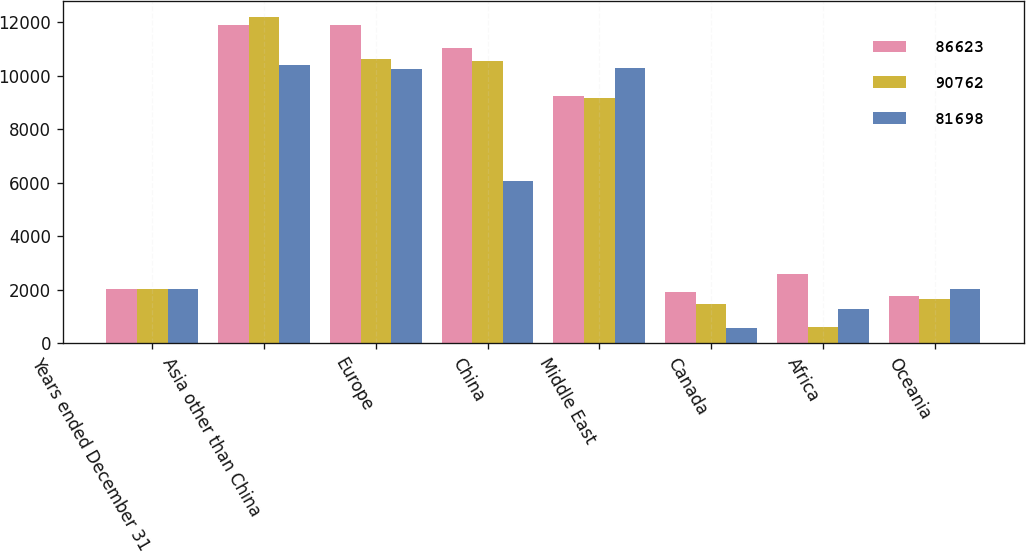Convert chart to OTSL. <chart><loc_0><loc_0><loc_500><loc_500><stacked_bar_chart><ecel><fcel>Years ended December 31<fcel>Asia other than China<fcel>Europe<fcel>China<fcel>Middle East<fcel>Canada<fcel>Africa<fcel>Oceania<nl><fcel>86623<fcel>2014<fcel>11900<fcel>11898<fcel>11029<fcel>9243<fcel>1901<fcel>2596<fcel>1757<nl><fcel>90762<fcel>2013<fcel>12200<fcel>10622<fcel>10555<fcel>9165<fcel>1486<fcel>621<fcel>1657<nl><fcel>81698<fcel>2012<fcel>10390<fcel>10269<fcel>6086<fcel>10285<fcel>586<fcel>1282<fcel>2043<nl></chart> 